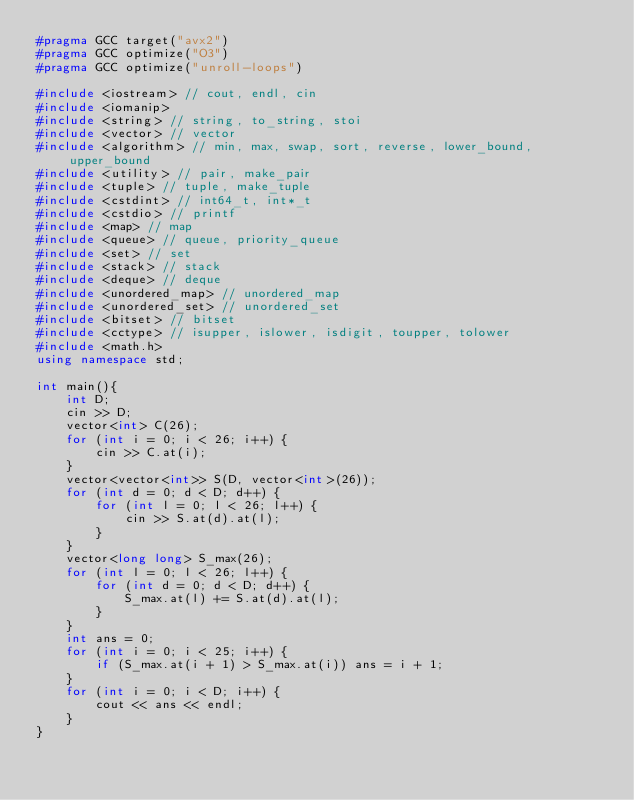Convert code to text. <code><loc_0><loc_0><loc_500><loc_500><_C++_>#pragma GCC target("avx2")
#pragma GCC optimize("O3")
#pragma GCC optimize("unroll-loops")

#include <iostream> // cout, endl, cin
#include <iomanip>
#include <string> // string, to_string, stoi
#include <vector> // vector
#include <algorithm> // min, max, swap, sort, reverse, lower_bound, upper_bound
#include <utility> // pair, make_pair
#include <tuple> // tuple, make_tuple
#include <cstdint> // int64_t, int*_t
#include <cstdio> // printf
#include <map> // map
#include <queue> // queue, priority_queue
#include <set> // set
#include <stack> // stack
#include <deque> // deque
#include <unordered_map> // unordered_map
#include <unordered_set> // unordered_set
#include <bitset> // bitset
#include <cctype> // isupper, islower, isdigit, toupper, tolower
#include <math.h>
using namespace std;

int main(){
	int D;
	cin >> D;
	vector<int> C(26);
	for (int i = 0; i < 26; i++) {
		cin >> C.at(i);
	}
	vector<vector<int>> S(D, vector<int>(26));
	for (int d = 0; d < D; d++) {
		for (int l = 0; l < 26; l++) {
			cin >> S.at(d).at(l);
		}
	}
	vector<long long> S_max(26);
	for (int l = 0; l < 26; l++) {
		for (int d = 0; d < D; d++) {
			S_max.at(l) += S.at(d).at(l);
		}
	}
	int ans = 0;
	for (int i = 0; i < 25; i++) {
		if (S_max.at(i + 1) > S_max.at(i)) ans = i + 1;
	}
	for (int i = 0; i < D; i++) {
		cout << ans << endl;
	}
}
</code> 